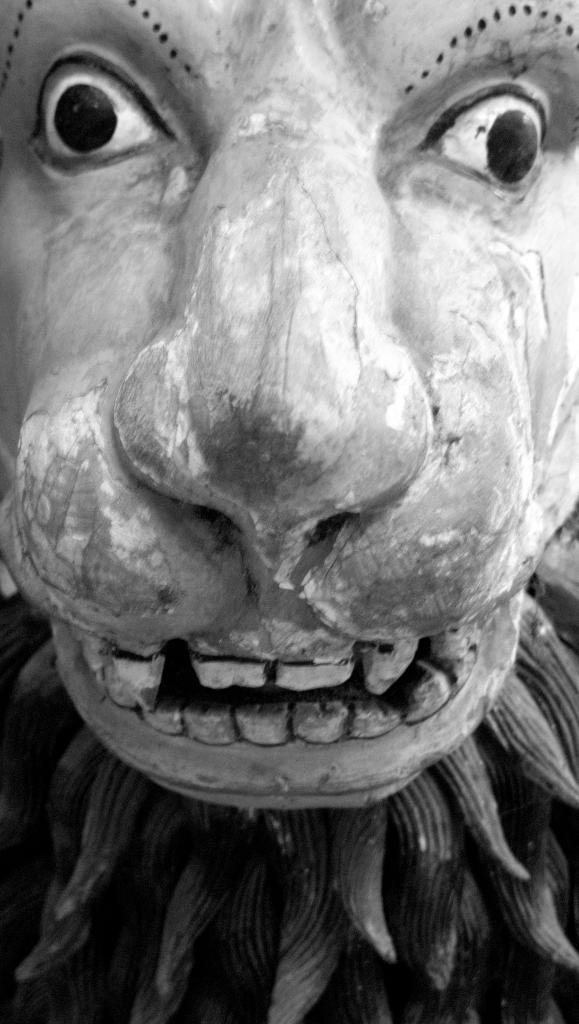What is the color scheme of the image? The image is black and white. What can be seen in the image? There is a sculpture in the image. How many rails can be seen in the image? There are no rails present in the image; it features a sculpture in a black and white color scheme. What type of tiger is depicted in the sculpture? There is no tiger depicted in the image, as it only features a sculpture without any specific details about its subject matter. 